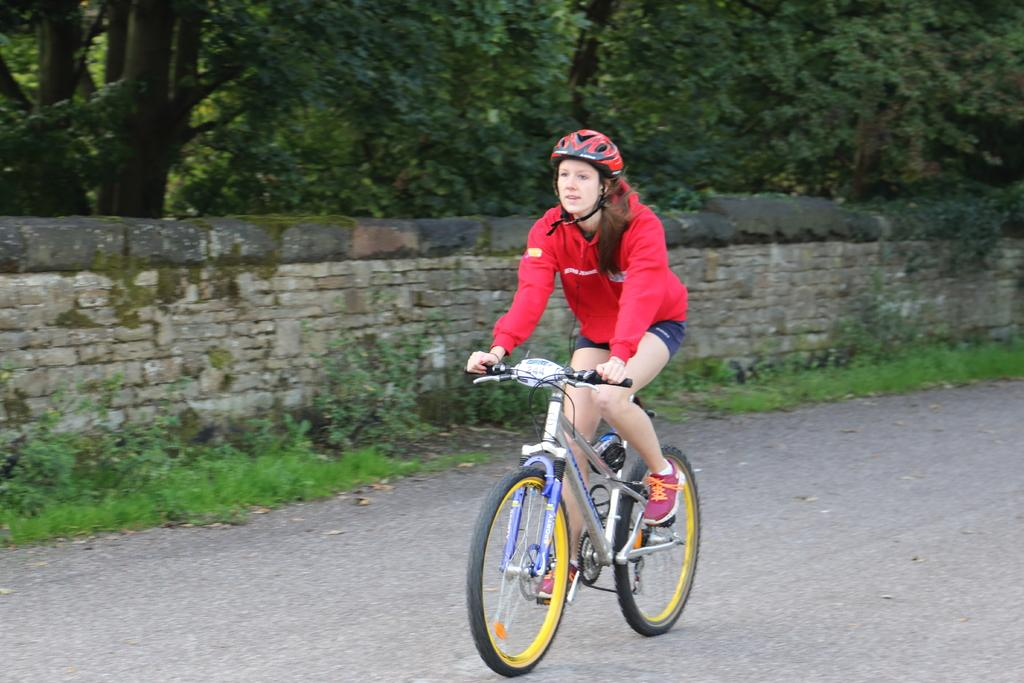What is the person in the image doing? The person is riding a bicycle on the road. What type of natural elements can be seen in the image? There are plants, trees, and grass visible in the image. What man-made structure is present in the image? There is a wall in the image. Can you see any ghosts arguing with the person riding the bicycle in the image? No, there are no ghosts or arguments present in the image. 